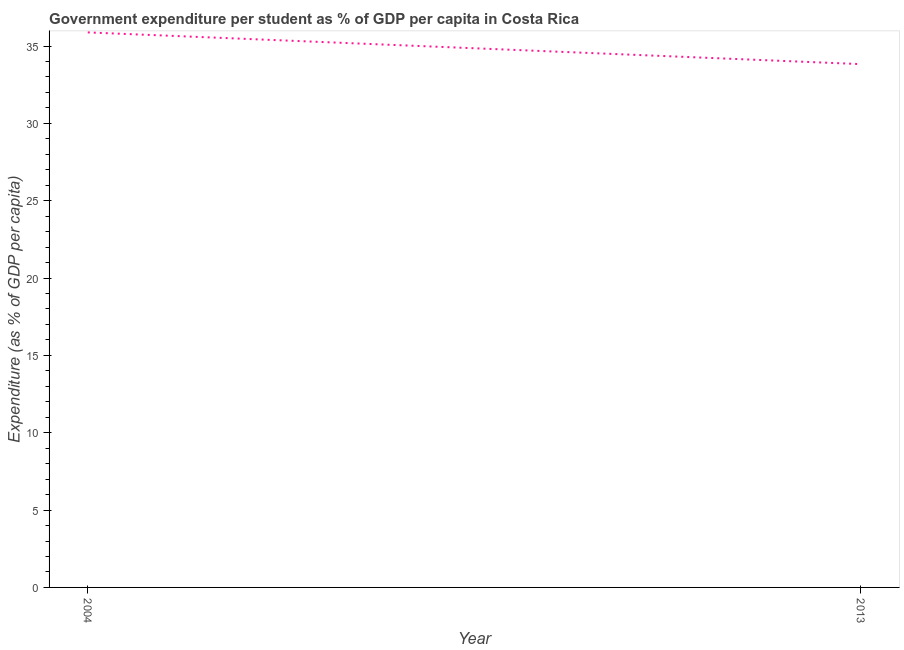What is the government expenditure per student in 2013?
Offer a very short reply. 33.83. Across all years, what is the maximum government expenditure per student?
Your response must be concise. 35.88. Across all years, what is the minimum government expenditure per student?
Your response must be concise. 33.83. What is the sum of the government expenditure per student?
Your response must be concise. 69.71. What is the difference between the government expenditure per student in 2004 and 2013?
Keep it short and to the point. 2.05. What is the average government expenditure per student per year?
Keep it short and to the point. 34.85. What is the median government expenditure per student?
Offer a very short reply. 34.85. What is the ratio of the government expenditure per student in 2004 to that in 2013?
Your answer should be very brief. 1.06. Is the government expenditure per student in 2004 less than that in 2013?
Provide a succinct answer. No. How many lines are there?
Offer a terse response. 1. How many years are there in the graph?
Offer a very short reply. 2. What is the difference between two consecutive major ticks on the Y-axis?
Provide a succinct answer. 5. Are the values on the major ticks of Y-axis written in scientific E-notation?
Your answer should be very brief. No. Does the graph contain any zero values?
Your answer should be very brief. No. Does the graph contain grids?
Make the answer very short. No. What is the title of the graph?
Your answer should be compact. Government expenditure per student as % of GDP per capita in Costa Rica. What is the label or title of the X-axis?
Your response must be concise. Year. What is the label or title of the Y-axis?
Make the answer very short. Expenditure (as % of GDP per capita). What is the Expenditure (as % of GDP per capita) of 2004?
Provide a short and direct response. 35.88. What is the Expenditure (as % of GDP per capita) in 2013?
Your answer should be compact. 33.83. What is the difference between the Expenditure (as % of GDP per capita) in 2004 and 2013?
Make the answer very short. 2.05. What is the ratio of the Expenditure (as % of GDP per capita) in 2004 to that in 2013?
Give a very brief answer. 1.06. 